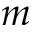Convert formula to latex. <formula><loc_0><loc_0><loc_500><loc_500>m</formula> 